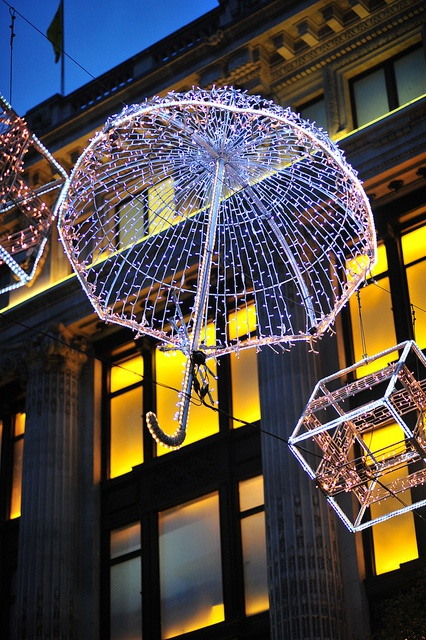Describe the objects in this image and their specific colors. I can see a umbrella in darkblue, black, lavender, darkgray, and navy tones in this image. 